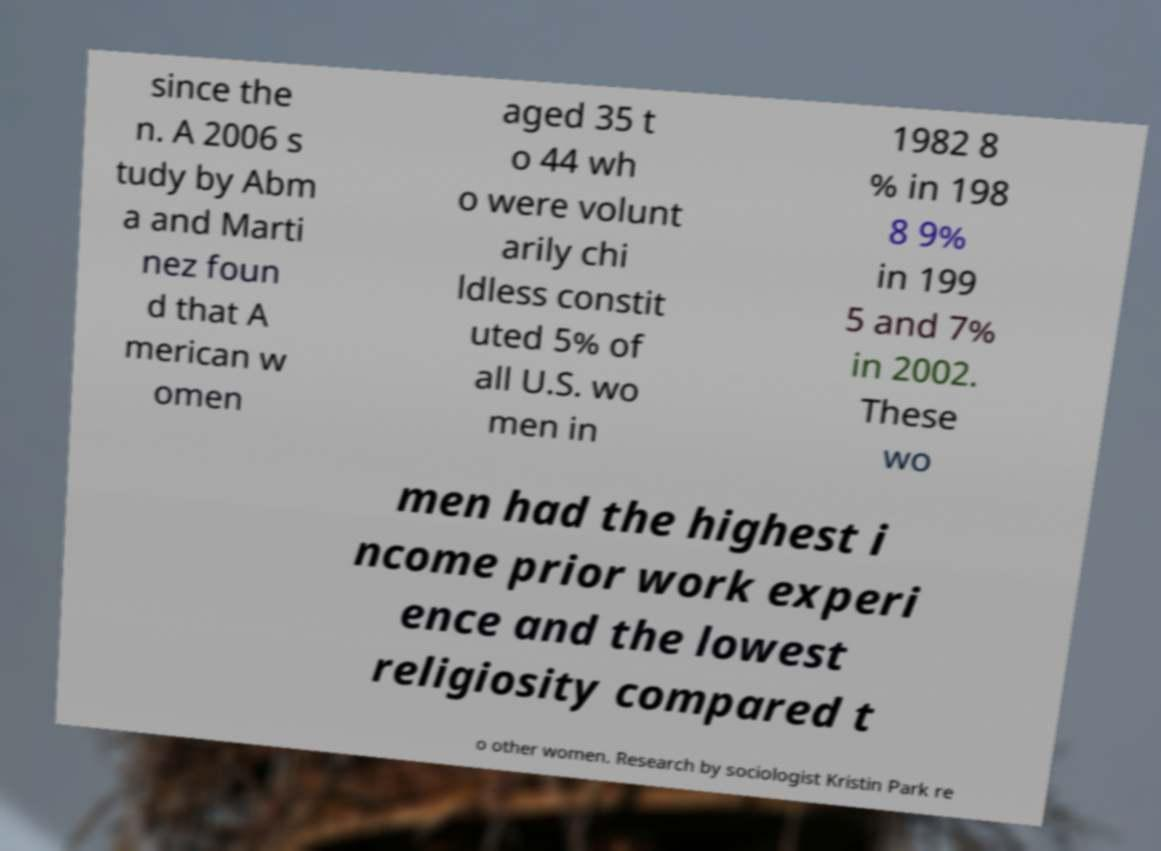What messages or text are displayed in this image? I need them in a readable, typed format. since the n. A 2006 s tudy by Abm a and Marti nez foun d that A merican w omen aged 35 t o 44 wh o were volunt arily chi ldless constit uted 5% of all U.S. wo men in 1982 8 % in 198 8 9% in 199 5 and 7% in 2002. These wo men had the highest i ncome prior work experi ence and the lowest religiosity compared t o other women. Research by sociologist Kristin Park re 